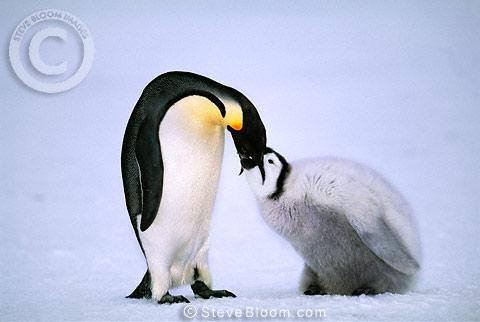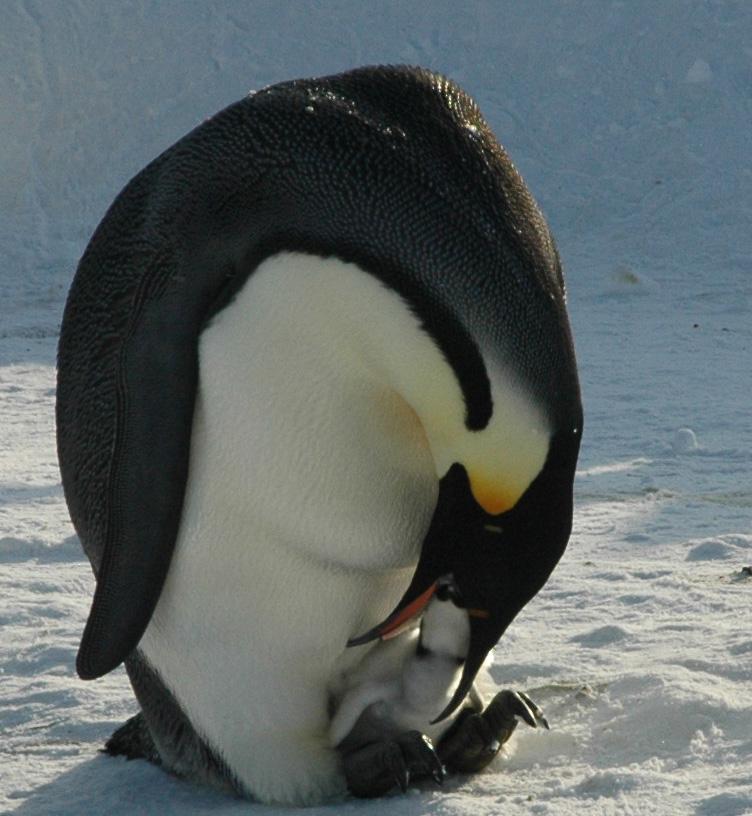The first image is the image on the left, the second image is the image on the right. Considering the images on both sides, is "An image shows a penguin poking its mostly closed beak in the fuzzy feathers of another penguin." valid? Answer yes or no. No. 